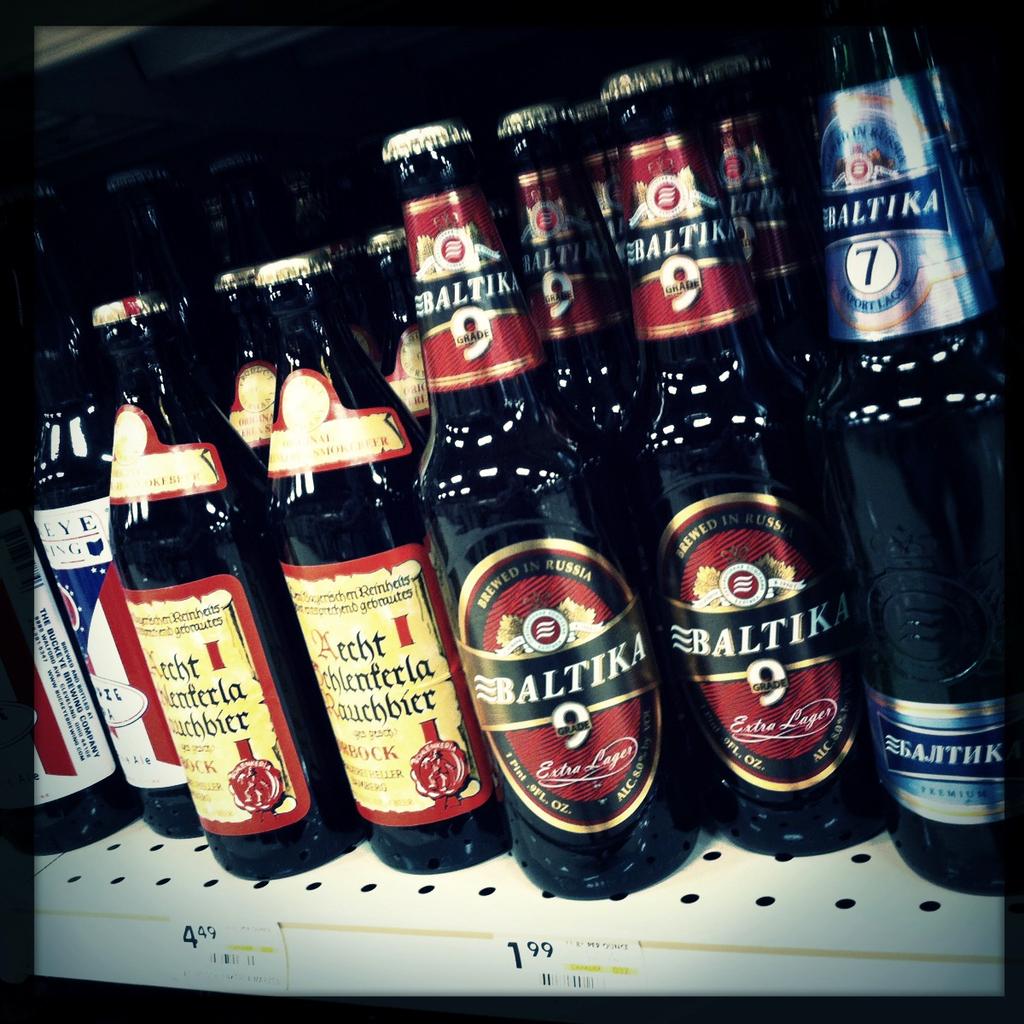What is the brand name of the beer with the oval-shaped sticker?
Ensure brevity in your answer.  Baltika. 